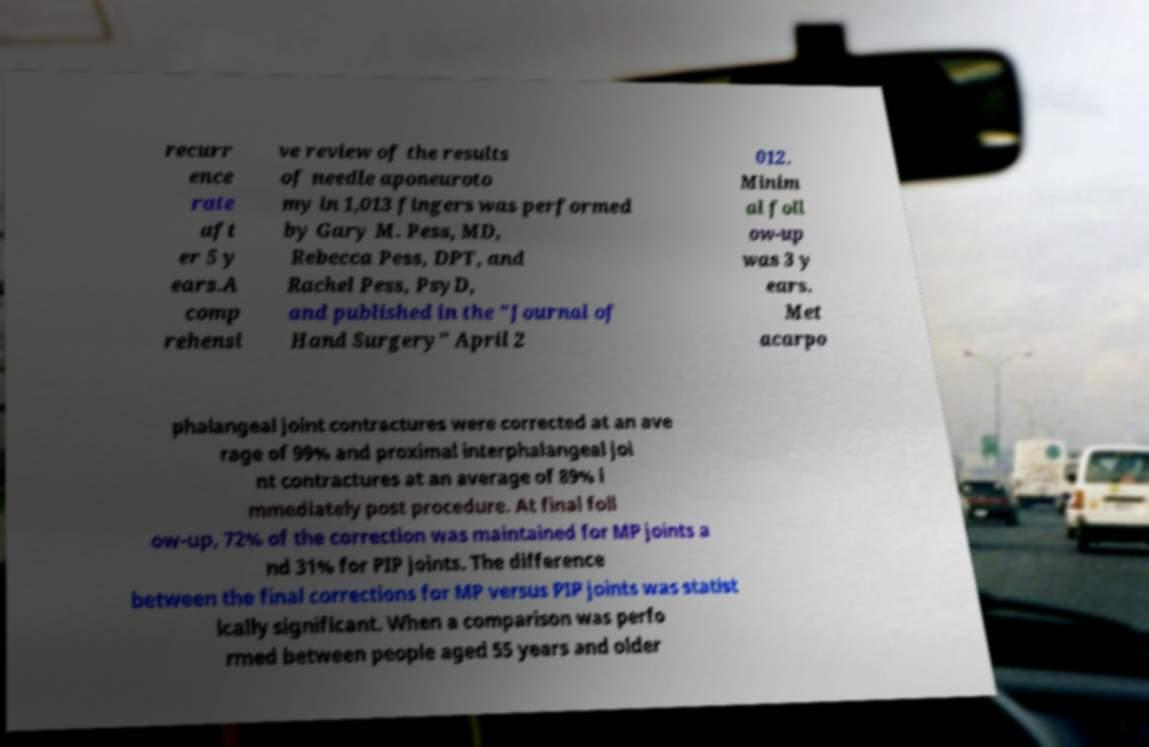Please identify and transcribe the text found in this image. recurr ence rate aft er 5 y ears.A comp rehensi ve review of the results of needle aponeuroto my in 1,013 fingers was performed by Gary M. Pess, MD, Rebecca Pess, DPT, and Rachel Pess, PsyD, and published in the "Journal of Hand Surgery" April 2 012. Minim al foll ow-up was 3 y ears. Met acarpo phalangeal joint contractures were corrected at an ave rage of 99% and proximal interphalangeal joi nt contractures at an average of 89% i mmediately post procedure. At final foll ow-up, 72% of the correction was maintained for MP joints a nd 31% for PIP joints. The difference between the final corrections for MP versus PIP joints was statist ically significant. When a comparison was perfo rmed between people aged 55 years and older 